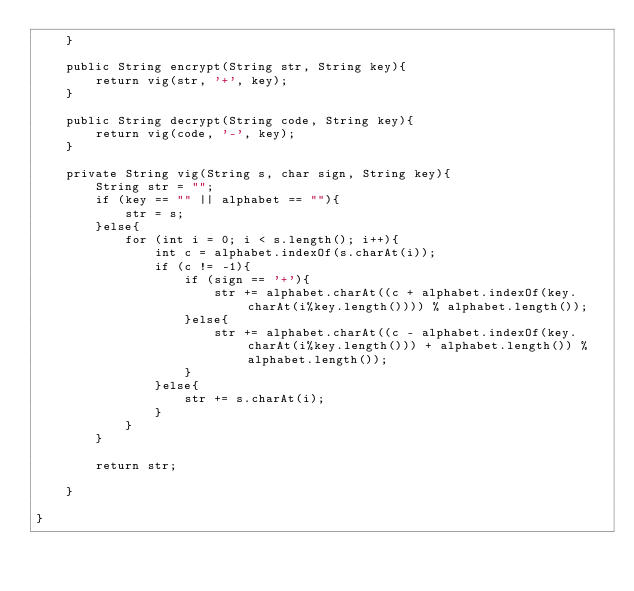Convert code to text. <code><loc_0><loc_0><loc_500><loc_500><_Java_>    }

    public String encrypt(String str, String key){
        return vig(str, '+', key);
    }

    public String decrypt(String code, String key){
        return vig(code, '-', key);
    }

    private String vig(String s, char sign, String key){
        String str = "";
        if (key == "" || alphabet == ""){
            str = s;
        }else{
            for (int i = 0; i < s.length(); i++){
                int c = alphabet.indexOf(s.charAt(i));
                if (c != -1){
                    if (sign == '+'){
                        str += alphabet.charAt((c + alphabet.indexOf(key.charAt(i%key.length()))) % alphabet.length());
                    }else{
                        str += alphabet.charAt((c - alphabet.indexOf(key.charAt(i%key.length())) + alphabet.length()) % alphabet.length());
                    }
                }else{
                    str += s.charAt(i);
                }
            }
        }

        return str;

    }

}

</code> 